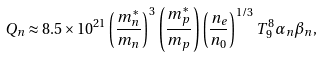<formula> <loc_0><loc_0><loc_500><loc_500>Q _ { n } \approx 8 . 5 \times 1 0 ^ { 2 1 } \left ( \frac { m _ { n } ^ { * } } { m _ { n } } \right ) ^ { 3 } \left ( \frac { m _ { p } ^ { * } } { m _ { p } } \right ) \left ( \frac { n _ { e } } { n _ { 0 } } \right ) ^ { 1 / 3 } T _ { 9 } ^ { 8 } \alpha _ { n } \beta _ { n } ,</formula> 